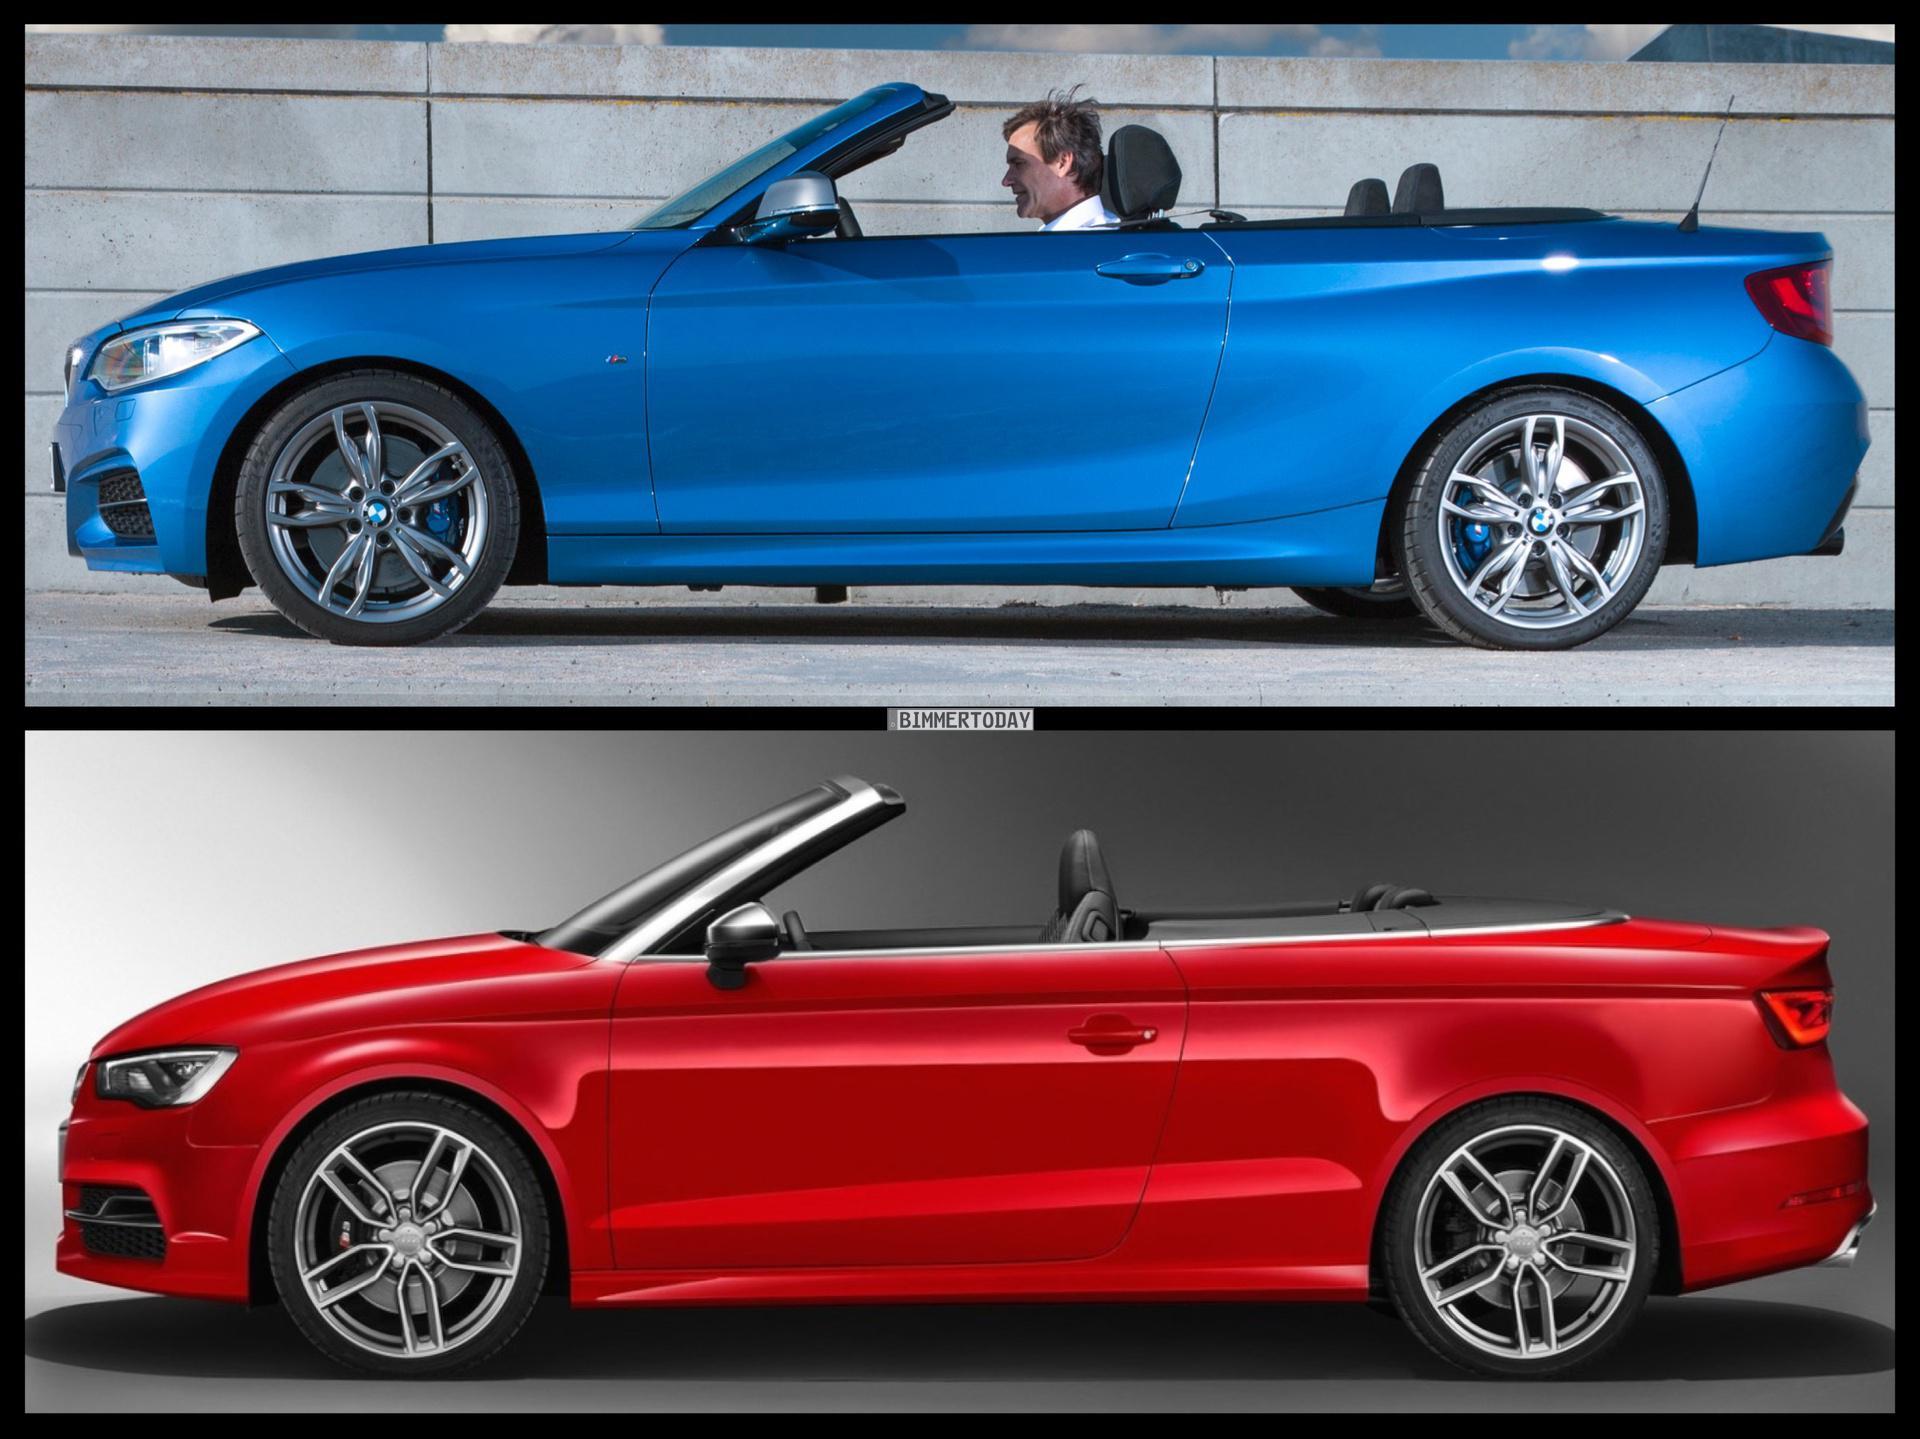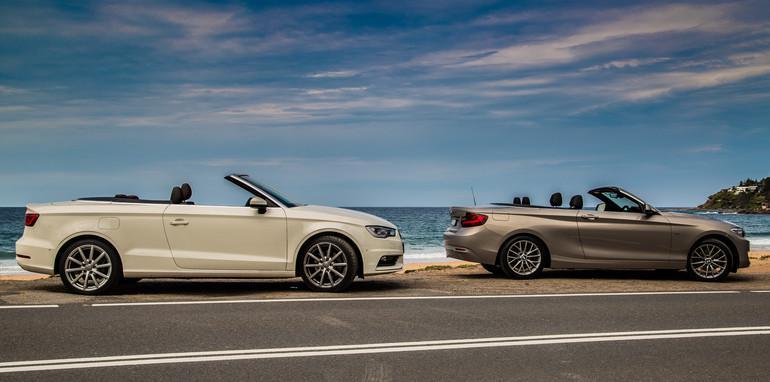The first image is the image on the left, the second image is the image on the right. Considering the images on both sides, is "One image features a cream-colored convertible and a taupe convertible, both topless and parked in front of water." valid? Answer yes or no. Yes. The first image is the image on the left, the second image is the image on the right. Examine the images to the left and right. Is the description "The right image contains two convertible vehicles." accurate? Answer yes or no. Yes. 